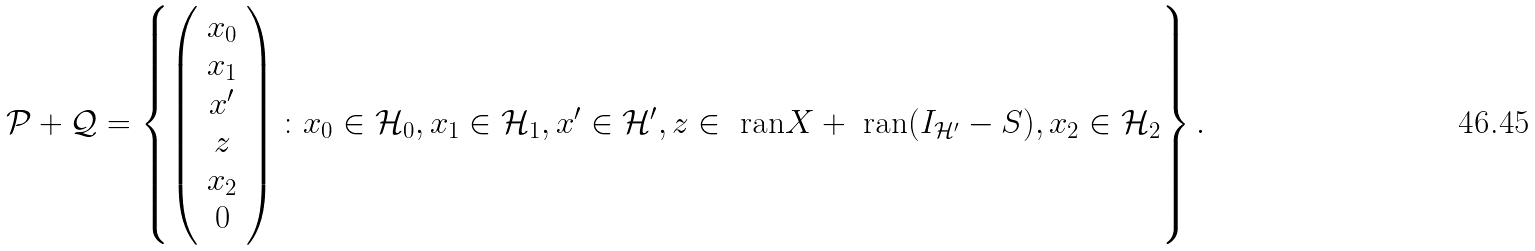<formula> <loc_0><loc_0><loc_500><loc_500>\mathcal { P } + \mathcal { Q } = \left \{ \left ( \begin{array} { c } x _ { 0 } \\ x _ { 1 } \\ x ^ { \prime } \\ z \\ x _ { 2 } \\ 0 \end{array} \right ) \colon x _ { 0 } \in \mathcal { H } _ { 0 } , x _ { 1 } \in \mathcal { H } _ { 1 } , x ^ { \prime } \in \mathcal { H } ^ { \prime } , z \in \text { ran} X + \text { ran} ( I _ { \mathcal { H } ^ { \prime } } - S ) , x _ { 2 } \in \mathcal { H } _ { 2 } \right \} .</formula> 